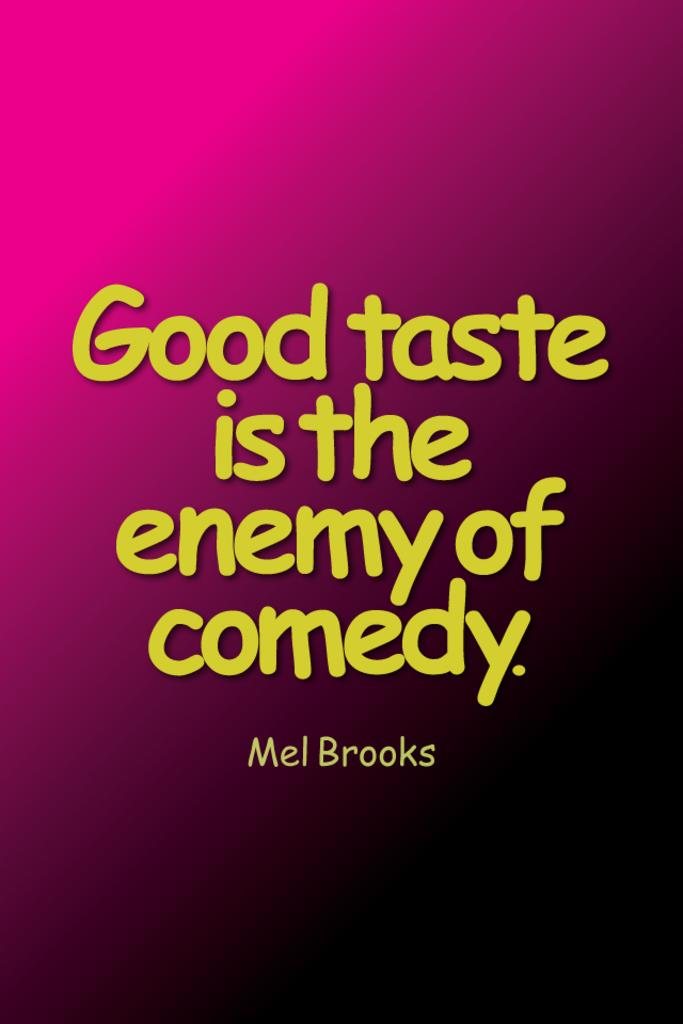Provide a one-sentence caption for the provided image. A text quote by Mel brooks on a pink gradient background which reads: "Good taste is the enemy of comedy". 